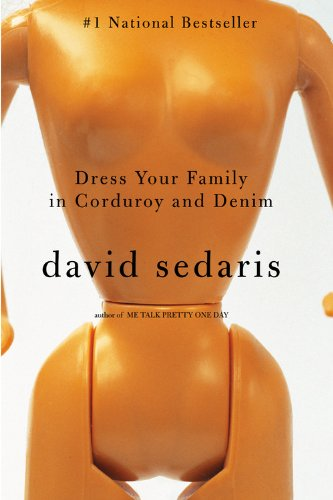Who is the author of this book? The author of the book shown in the image is David Sedaris, a renowned author known for his witty and incisive humor. 